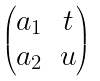Convert formula to latex. <formula><loc_0><loc_0><loc_500><loc_500>\begin{pmatrix} a _ { 1 } & t \\ a _ { 2 } & u \end{pmatrix}</formula> 